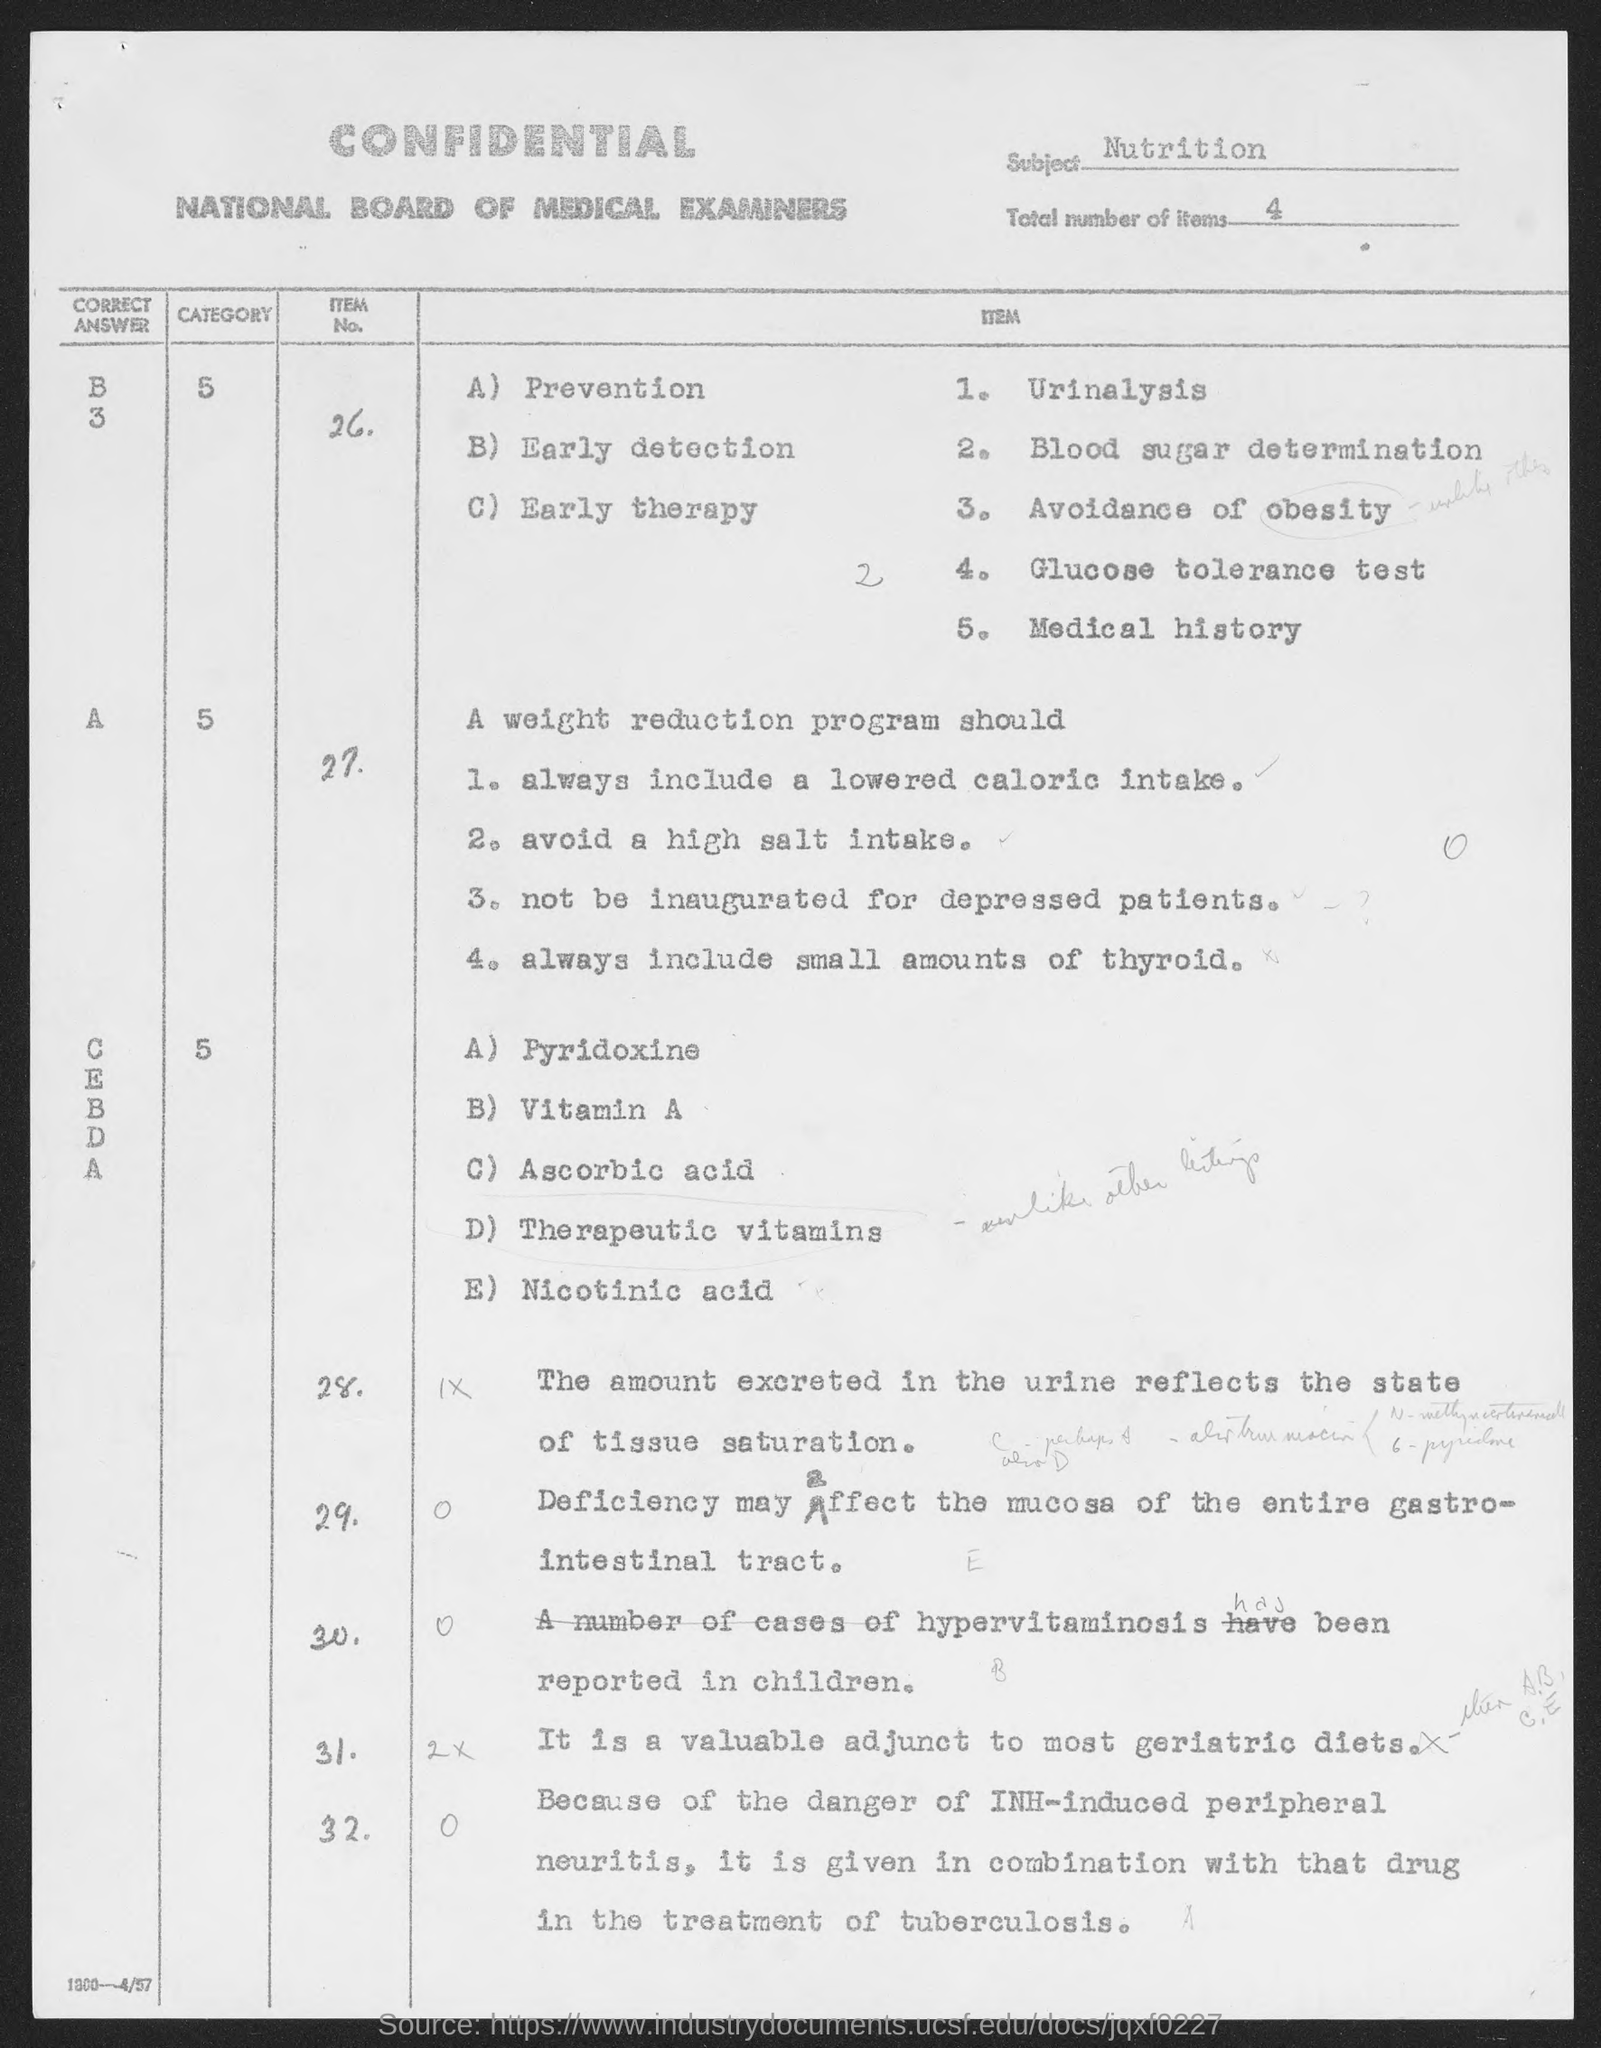What is the Subject?
Offer a terse response. NUTRITION. What are the total number of items?
Provide a succinct answer. 4. 